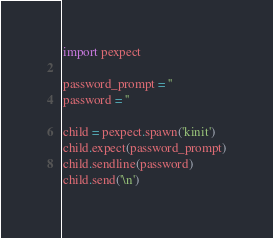<code> <loc_0><loc_0><loc_500><loc_500><_Python_>import pexpect

password_prompt = ''
password = ''

child = pexpect.spawn('kinit')
child.expect(password_prompt)
child.sendline(password)
child.send('\n')</code> 